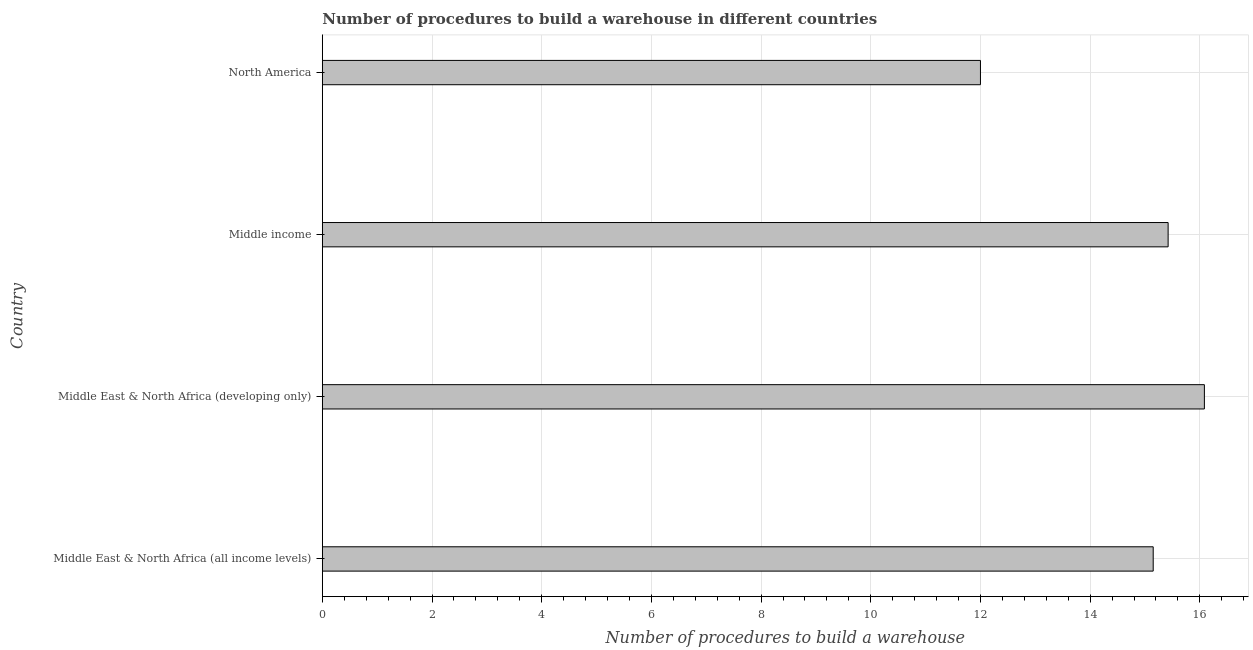What is the title of the graph?
Your answer should be compact. Number of procedures to build a warehouse in different countries. What is the label or title of the X-axis?
Provide a succinct answer. Number of procedures to build a warehouse. What is the label or title of the Y-axis?
Make the answer very short. Country. What is the number of procedures to build a warehouse in Middle East & North Africa (developing only)?
Provide a short and direct response. 16.08. Across all countries, what is the maximum number of procedures to build a warehouse?
Ensure brevity in your answer.  16.08. In which country was the number of procedures to build a warehouse maximum?
Offer a very short reply. Middle East & North Africa (developing only). What is the sum of the number of procedures to build a warehouse?
Your answer should be compact. 58.66. What is the difference between the number of procedures to build a warehouse in Middle East & North Africa (developing only) and Middle income?
Your response must be concise. 0.66. What is the average number of procedures to build a warehouse per country?
Your answer should be compact. 14.66. What is the median number of procedures to build a warehouse?
Make the answer very short. 15.29. In how many countries, is the number of procedures to build a warehouse greater than 14.8 ?
Ensure brevity in your answer.  3. What is the difference between the highest and the second highest number of procedures to build a warehouse?
Offer a very short reply. 0.66. What is the difference between the highest and the lowest number of procedures to build a warehouse?
Your answer should be compact. 4.08. In how many countries, is the number of procedures to build a warehouse greater than the average number of procedures to build a warehouse taken over all countries?
Provide a short and direct response. 3. Are all the bars in the graph horizontal?
Ensure brevity in your answer.  Yes. How many countries are there in the graph?
Offer a terse response. 4. What is the difference between two consecutive major ticks on the X-axis?
Your answer should be compact. 2. What is the Number of procedures to build a warehouse of Middle East & North Africa (all income levels)?
Offer a very short reply. 15.15. What is the Number of procedures to build a warehouse of Middle East & North Africa (developing only)?
Your answer should be very brief. 16.08. What is the Number of procedures to build a warehouse of Middle income?
Provide a succinct answer. 15.42. What is the difference between the Number of procedures to build a warehouse in Middle East & North Africa (all income levels) and Middle East & North Africa (developing only)?
Provide a short and direct response. -0.93. What is the difference between the Number of procedures to build a warehouse in Middle East & North Africa (all income levels) and Middle income?
Provide a succinct answer. -0.27. What is the difference between the Number of procedures to build a warehouse in Middle East & North Africa (all income levels) and North America?
Make the answer very short. 3.15. What is the difference between the Number of procedures to build a warehouse in Middle East & North Africa (developing only) and Middle income?
Offer a very short reply. 0.66. What is the difference between the Number of procedures to build a warehouse in Middle East & North Africa (developing only) and North America?
Make the answer very short. 4.08. What is the difference between the Number of procedures to build a warehouse in Middle income and North America?
Your response must be concise. 3.42. What is the ratio of the Number of procedures to build a warehouse in Middle East & North Africa (all income levels) to that in Middle East & North Africa (developing only)?
Offer a very short reply. 0.94. What is the ratio of the Number of procedures to build a warehouse in Middle East & North Africa (all income levels) to that in Middle income?
Ensure brevity in your answer.  0.98. What is the ratio of the Number of procedures to build a warehouse in Middle East & North Africa (all income levels) to that in North America?
Offer a terse response. 1.26. What is the ratio of the Number of procedures to build a warehouse in Middle East & North Africa (developing only) to that in Middle income?
Ensure brevity in your answer.  1.04. What is the ratio of the Number of procedures to build a warehouse in Middle East & North Africa (developing only) to that in North America?
Your response must be concise. 1.34. What is the ratio of the Number of procedures to build a warehouse in Middle income to that in North America?
Keep it short and to the point. 1.28. 